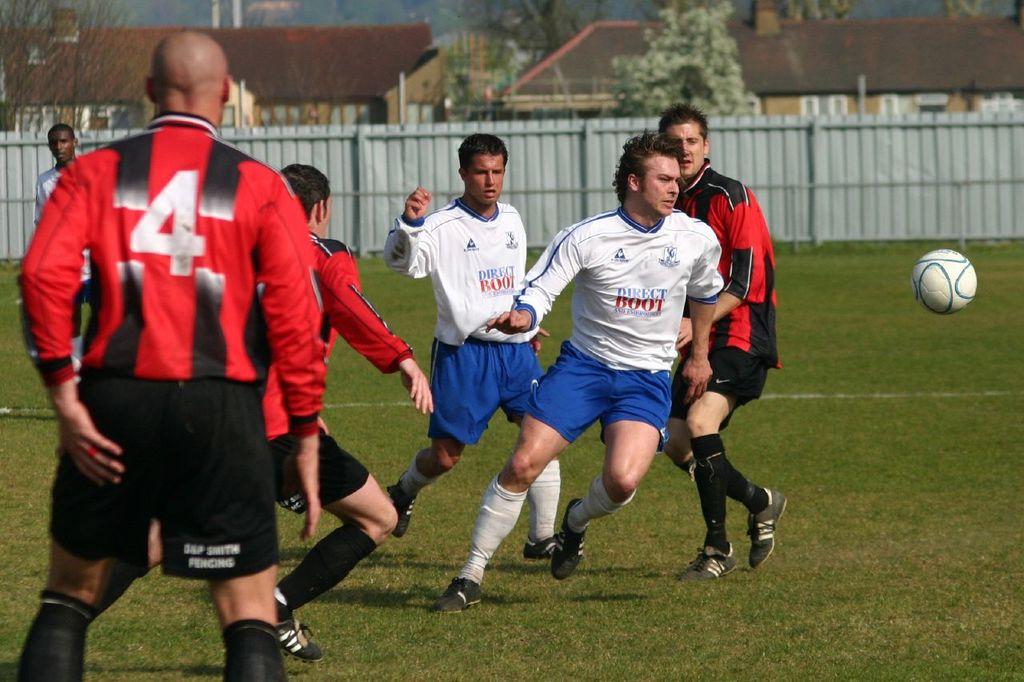What is the number of the ref?
Make the answer very short. 4. What number is the mans top?
Offer a very short reply. 4. 